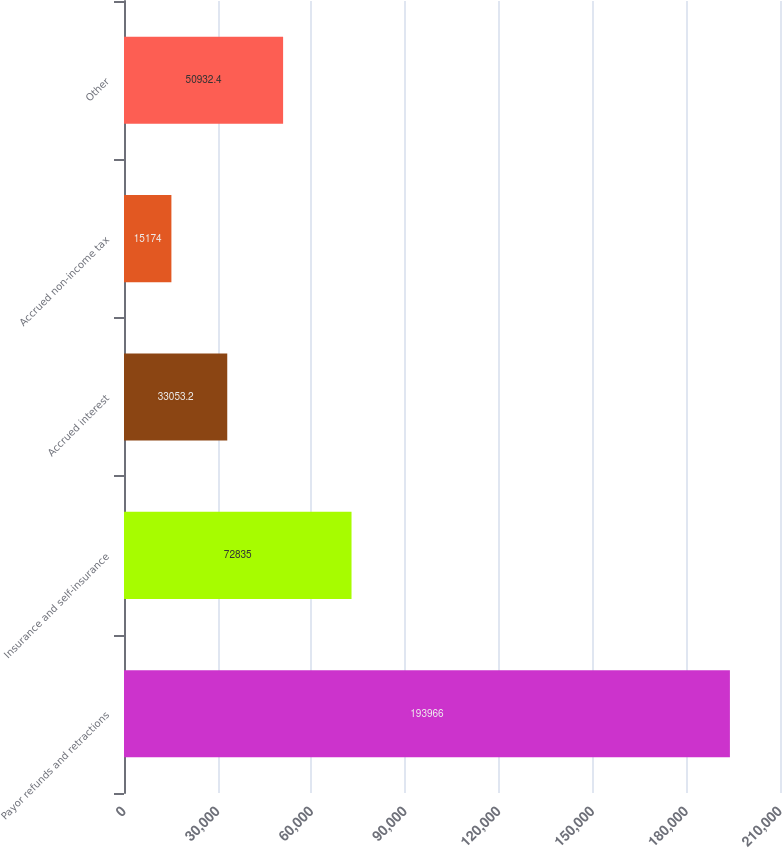Convert chart to OTSL. <chart><loc_0><loc_0><loc_500><loc_500><bar_chart><fcel>Payor refunds and retractions<fcel>Insurance and self-insurance<fcel>Accrued interest<fcel>Accrued non-income tax<fcel>Other<nl><fcel>193966<fcel>72835<fcel>33053.2<fcel>15174<fcel>50932.4<nl></chart> 